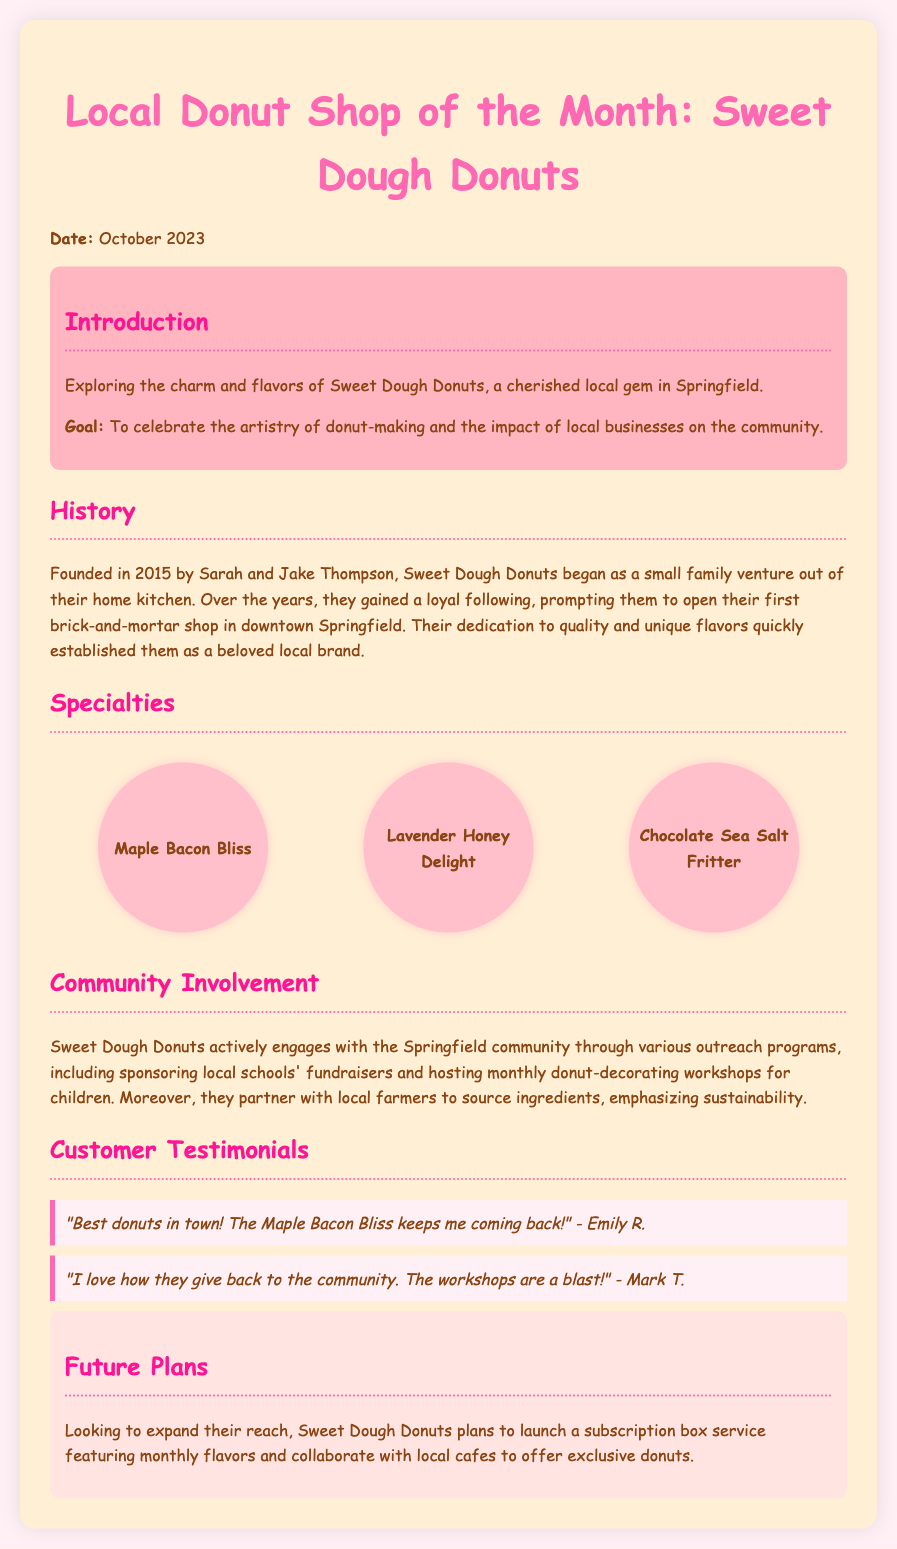What is the name of the donut shop featured? The name of the featured donut shop is mentioned in the title of the document.
Answer: Sweet Dough Donuts In which year was Sweet Dough Donuts founded? The founding year is provided in the history section of the document.
Answer: 2015 Who are the founders of Sweet Dough Donuts? The names of the founders are stated in the history section of the document.
Answer: Sarah and Jake Thompson What is one of the specialties of Sweet Dough Donuts? The specialties of the shop are listed in the specialties section of the document.
Answer: Maple Bacon Bliss What community activity does Sweet Dough Donuts engage in? The document details various activities related to community involvement of the shop.
Answer: Sponsoring local schools' fundraisers How do the owners of Sweet Dough Donuts emphasize sustainability? The emphasis on sustainability is found in the community involvement section regarding ingredient sourcing.
Answer: Partner with local farmers What future plan involves collaborations with local cafes? The future plans section includes details about collaborations for a specific service.
Answer: Exclusive donuts Which month is the donut shop of the month being celebrated? The month of celebration is noted at the beginning of the document.
Answer: October 